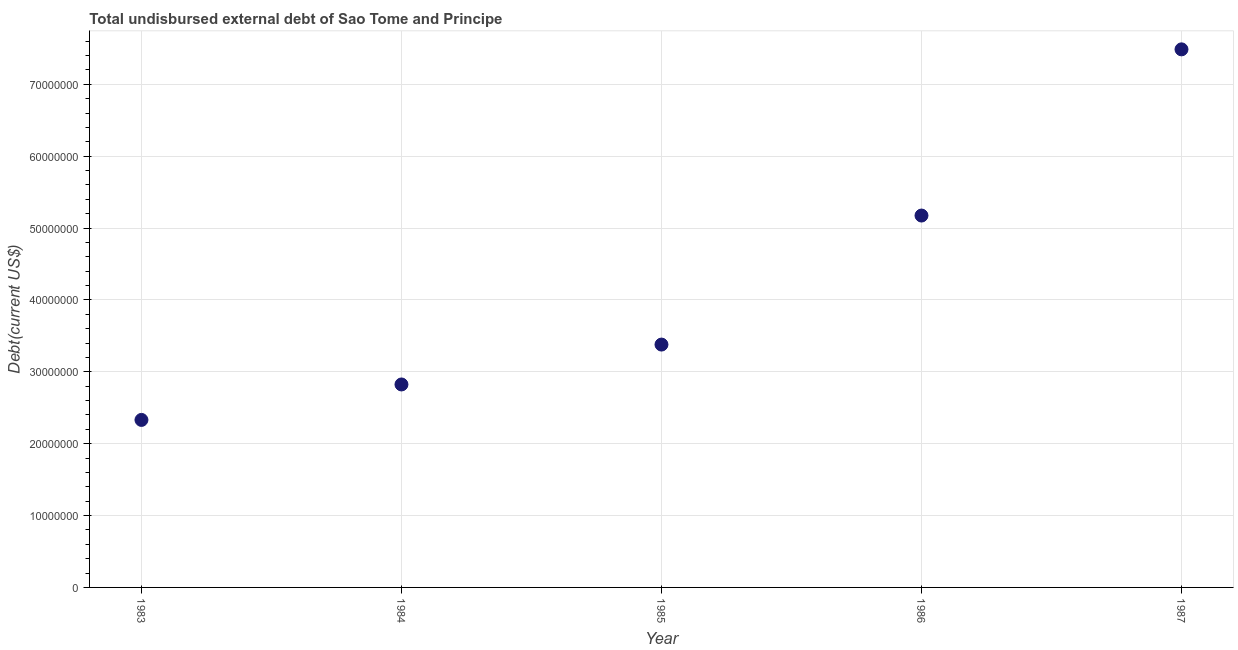What is the total debt in 1984?
Provide a short and direct response. 2.82e+07. Across all years, what is the maximum total debt?
Give a very brief answer. 7.49e+07. Across all years, what is the minimum total debt?
Your response must be concise. 2.33e+07. What is the sum of the total debt?
Offer a very short reply. 2.12e+08. What is the difference between the total debt in 1985 and 1986?
Your answer should be very brief. -1.80e+07. What is the average total debt per year?
Your answer should be compact. 4.24e+07. What is the median total debt?
Offer a very short reply. 3.38e+07. What is the ratio of the total debt in 1985 to that in 1986?
Provide a short and direct response. 0.65. Is the total debt in 1983 less than that in 1987?
Give a very brief answer. Yes. Is the difference between the total debt in 1984 and 1985 greater than the difference between any two years?
Offer a very short reply. No. What is the difference between the highest and the second highest total debt?
Keep it short and to the point. 2.31e+07. What is the difference between the highest and the lowest total debt?
Your response must be concise. 5.16e+07. In how many years, is the total debt greater than the average total debt taken over all years?
Provide a succinct answer. 2. Does the total debt monotonically increase over the years?
Provide a short and direct response. Yes. How many dotlines are there?
Your answer should be compact. 1. How many years are there in the graph?
Ensure brevity in your answer.  5. Does the graph contain any zero values?
Provide a succinct answer. No. Does the graph contain grids?
Provide a short and direct response. Yes. What is the title of the graph?
Make the answer very short. Total undisbursed external debt of Sao Tome and Principe. What is the label or title of the Y-axis?
Ensure brevity in your answer.  Debt(current US$). What is the Debt(current US$) in 1983?
Offer a terse response. 2.33e+07. What is the Debt(current US$) in 1984?
Your answer should be very brief. 2.82e+07. What is the Debt(current US$) in 1985?
Your response must be concise. 3.38e+07. What is the Debt(current US$) in 1986?
Provide a succinct answer. 5.17e+07. What is the Debt(current US$) in 1987?
Make the answer very short. 7.49e+07. What is the difference between the Debt(current US$) in 1983 and 1984?
Make the answer very short. -4.93e+06. What is the difference between the Debt(current US$) in 1983 and 1985?
Ensure brevity in your answer.  -1.05e+07. What is the difference between the Debt(current US$) in 1983 and 1986?
Your response must be concise. -2.84e+07. What is the difference between the Debt(current US$) in 1983 and 1987?
Make the answer very short. -5.16e+07. What is the difference between the Debt(current US$) in 1984 and 1985?
Offer a terse response. -5.55e+06. What is the difference between the Debt(current US$) in 1984 and 1986?
Ensure brevity in your answer.  -2.35e+07. What is the difference between the Debt(current US$) in 1984 and 1987?
Your answer should be very brief. -4.66e+07. What is the difference between the Debt(current US$) in 1985 and 1986?
Give a very brief answer. -1.80e+07. What is the difference between the Debt(current US$) in 1985 and 1987?
Give a very brief answer. -4.11e+07. What is the difference between the Debt(current US$) in 1986 and 1987?
Your response must be concise. -2.31e+07. What is the ratio of the Debt(current US$) in 1983 to that in 1984?
Keep it short and to the point. 0.82. What is the ratio of the Debt(current US$) in 1983 to that in 1985?
Provide a short and direct response. 0.69. What is the ratio of the Debt(current US$) in 1983 to that in 1986?
Offer a very short reply. 0.45. What is the ratio of the Debt(current US$) in 1983 to that in 1987?
Provide a succinct answer. 0.31. What is the ratio of the Debt(current US$) in 1984 to that in 1985?
Your answer should be compact. 0.84. What is the ratio of the Debt(current US$) in 1984 to that in 1986?
Ensure brevity in your answer.  0.55. What is the ratio of the Debt(current US$) in 1984 to that in 1987?
Keep it short and to the point. 0.38. What is the ratio of the Debt(current US$) in 1985 to that in 1986?
Offer a very short reply. 0.65. What is the ratio of the Debt(current US$) in 1985 to that in 1987?
Make the answer very short. 0.45. What is the ratio of the Debt(current US$) in 1986 to that in 1987?
Provide a succinct answer. 0.69. 